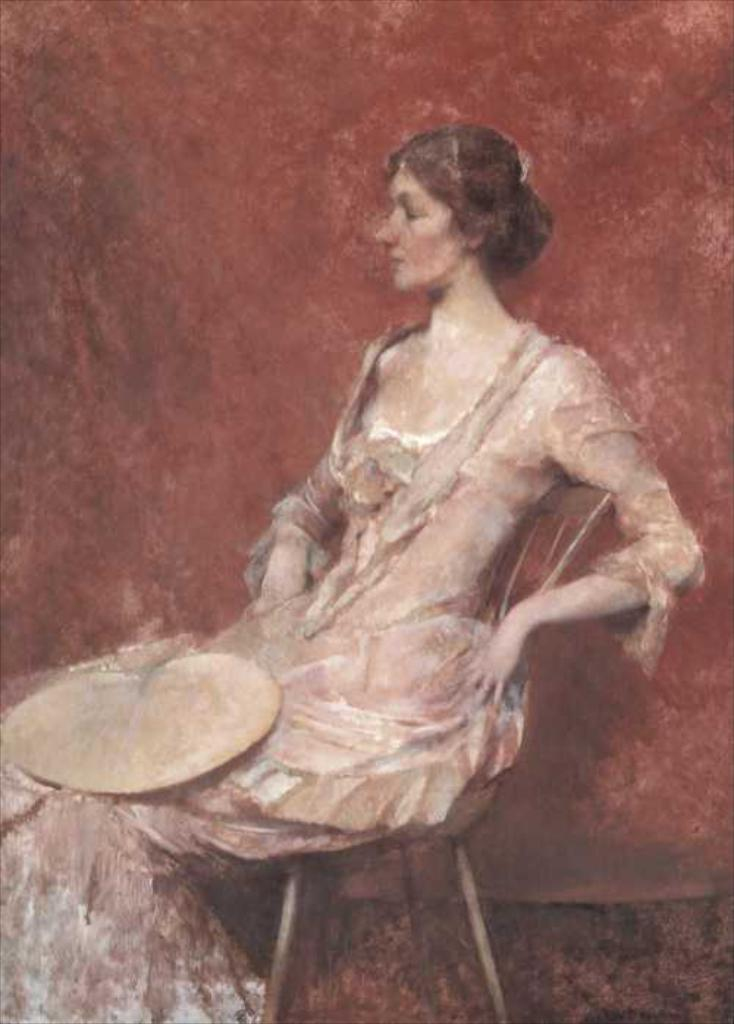What is the main subject of the image? There is a painting in the image. What is the woman in the painting doing? The painting depicts a woman sitting. What color is the background of the painting? The background of the painting is red. How many eggs are being used to care for the queen in the image? There are no eggs or queens present in the image; it features a painting of a woman sitting with a red background. 